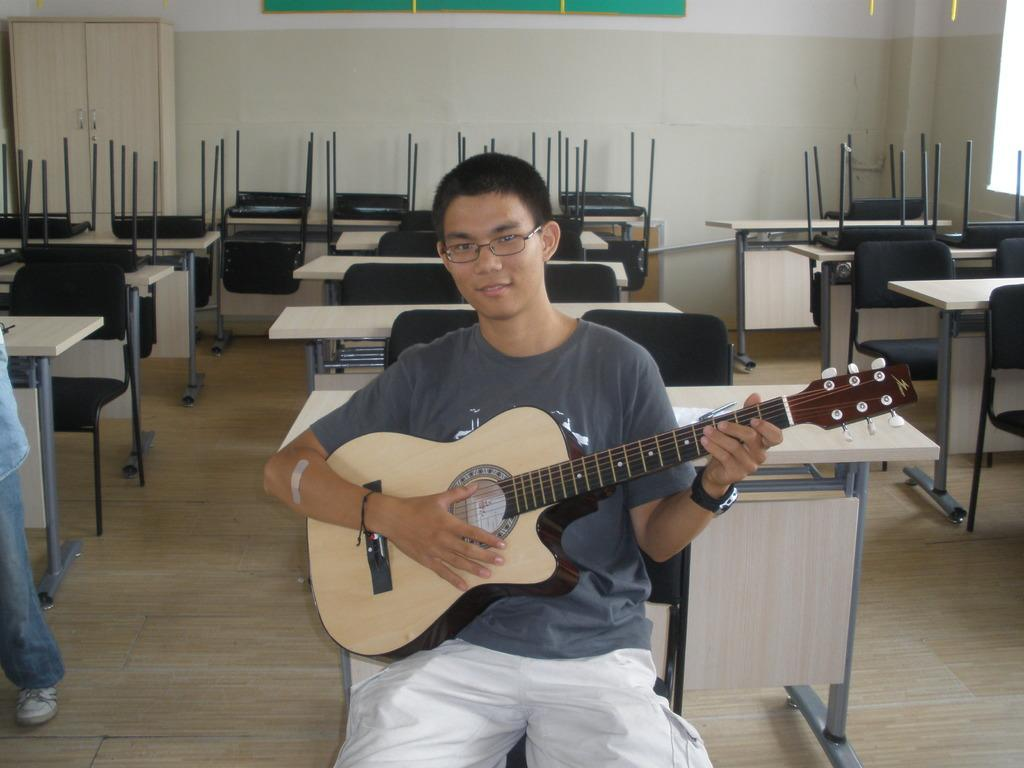What is the man in the image doing? The man is sitting and playing a guitar. What is the man wearing in the image? The man is wearing a grey t-shirt. What can be seen in the background of the image? There are many tables and chairs in the background. What is located in the left corner of the image? There is a cupboard in the left corner of the image. What type of wheel can be seen in the image? There is no wheel present in the image. Is there any fog visible in the image? There is no fog visible in the image. 